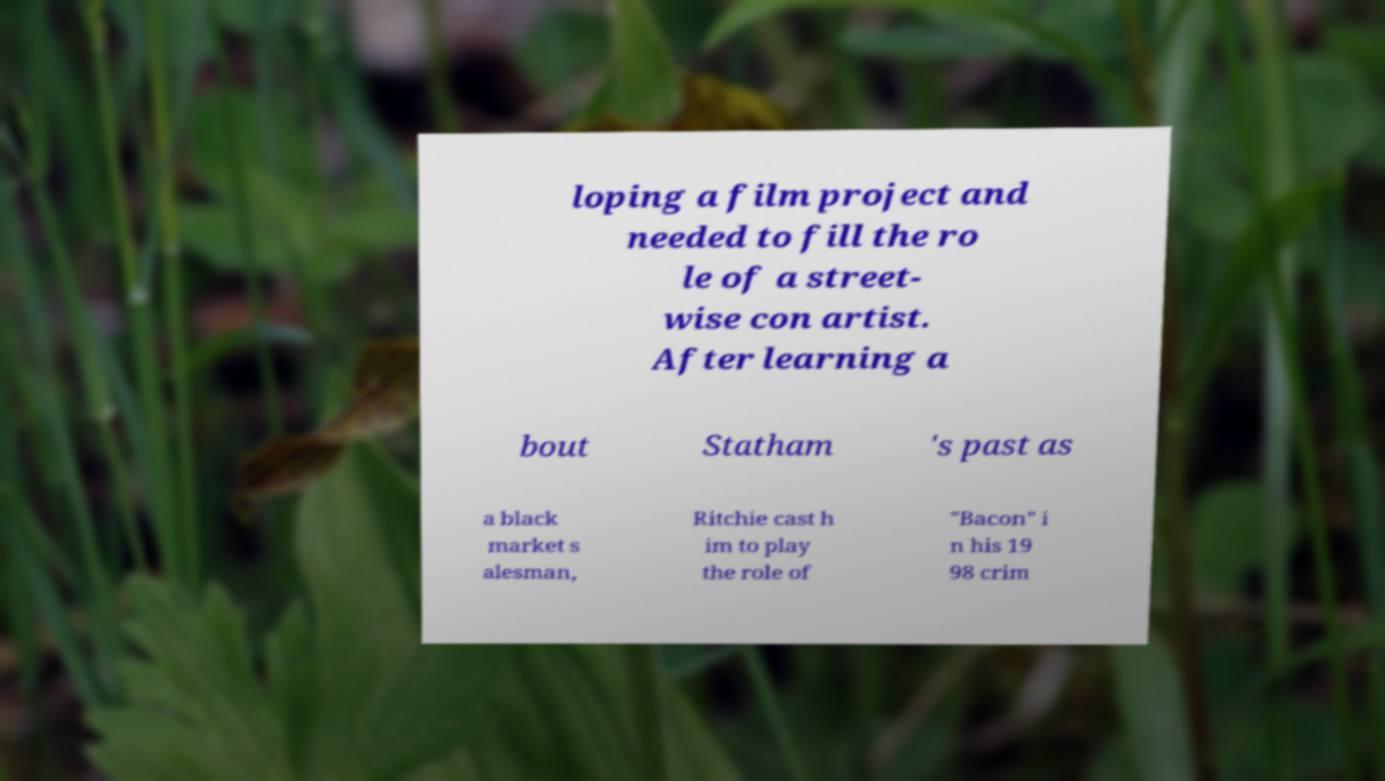I need the written content from this picture converted into text. Can you do that? loping a film project and needed to fill the ro le of a street- wise con artist. After learning a bout Statham 's past as a black market s alesman, Ritchie cast h im to play the role of "Bacon" i n his 19 98 crim 